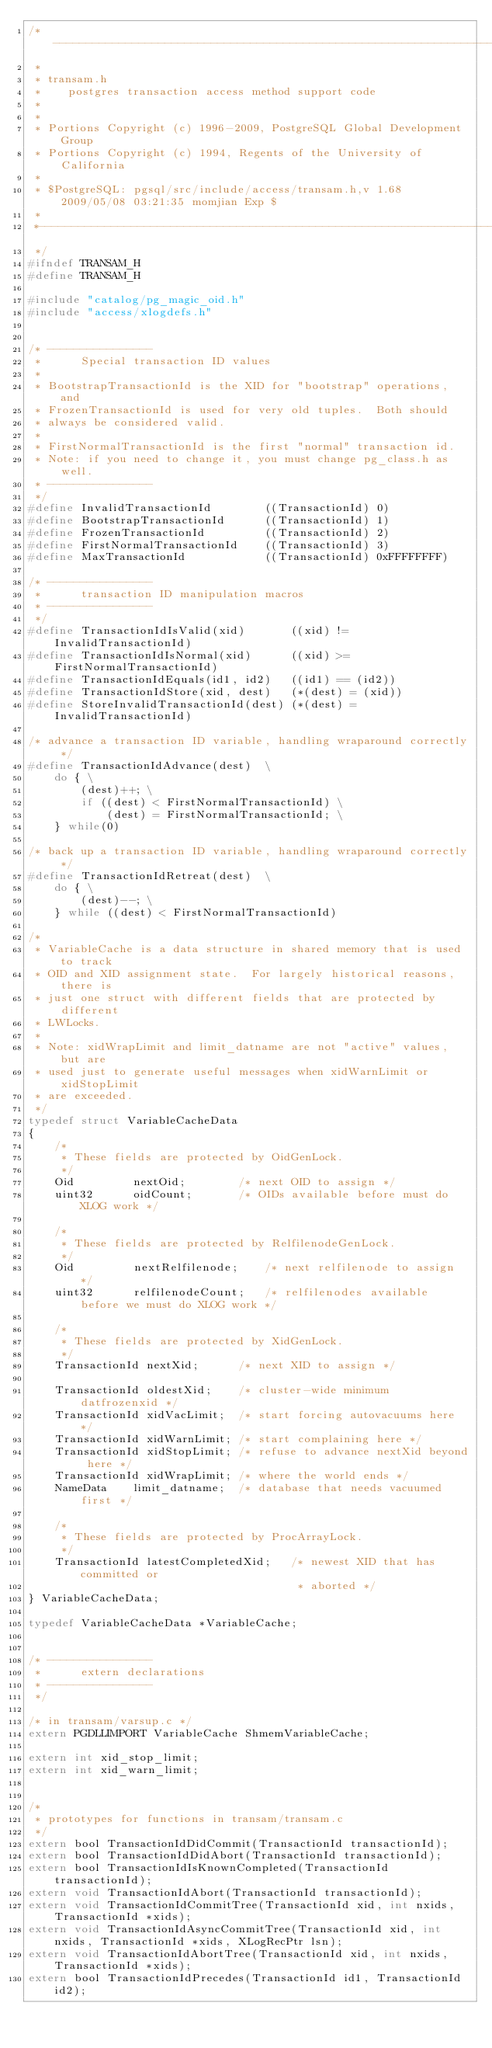<code> <loc_0><loc_0><loc_500><loc_500><_C_>/*-------------------------------------------------------------------------
 *
 * transam.h
 *	  postgres transaction access method support code
 *
 *
 * Portions Copyright (c) 1996-2009, PostgreSQL Global Development Group
 * Portions Copyright (c) 1994, Regents of the University of California
 *
 * $PostgreSQL: pgsql/src/include/access/transam.h,v 1.68 2009/05/08 03:21:35 momjian Exp $
 *
 *-------------------------------------------------------------------------
 */
#ifndef TRANSAM_H
#define TRANSAM_H

#include "catalog/pg_magic_oid.h"
#include "access/xlogdefs.h"


/* ----------------
 *		Special transaction ID values
 *
 * BootstrapTransactionId is the XID for "bootstrap" operations, and
 * FrozenTransactionId is used for very old tuples.  Both should
 * always be considered valid.
 *
 * FirstNormalTransactionId is the first "normal" transaction id.
 * Note: if you need to change it, you must change pg_class.h as well.
 * ----------------
 */
#define InvalidTransactionId		((TransactionId) 0)
#define BootstrapTransactionId		((TransactionId) 1)
#define FrozenTransactionId			((TransactionId) 2)
#define FirstNormalTransactionId	((TransactionId) 3)
#define MaxTransactionId			((TransactionId) 0xFFFFFFFF)

/* ----------------
 *		transaction ID manipulation macros
 * ----------------
 */
#define TransactionIdIsValid(xid)		((xid) != InvalidTransactionId)
#define TransactionIdIsNormal(xid)		((xid) >= FirstNormalTransactionId)
#define TransactionIdEquals(id1, id2)	((id1) == (id2))
#define TransactionIdStore(xid, dest)	(*(dest) = (xid))
#define StoreInvalidTransactionId(dest) (*(dest) = InvalidTransactionId)

/* advance a transaction ID variable, handling wraparound correctly */
#define TransactionIdAdvance(dest)	\
	do { \
		(dest)++; \
		if ((dest) < FirstNormalTransactionId) \
			(dest) = FirstNormalTransactionId; \
	} while(0)

/* back up a transaction ID variable, handling wraparound correctly */
#define TransactionIdRetreat(dest)	\
	do { \
		(dest)--; \
	} while ((dest) < FirstNormalTransactionId)

/*
 * VariableCache is a data structure in shared memory that is used to track
 * OID and XID assignment state.  For largely historical reasons, there is
 * just one struct with different fields that are protected by different
 * LWLocks.
 *
 * Note: xidWrapLimit and limit_datname are not "active" values, but are
 * used just to generate useful messages when xidWarnLimit or xidStopLimit
 * are exceeded.
 */
typedef struct VariableCacheData
{
	/*
	 * These fields are protected by OidGenLock.
	 */
	Oid			nextOid;		/* next OID to assign */
	uint32		oidCount;		/* OIDs available before must do XLOG work */

	/*
	 * These fields are protected by RelfilenodeGenLock.
	 */
	Oid			nextRelfilenode;	/* next relfilenode to assign */
	uint32		relfilenodeCount;	/* relfilenodes available before we must do XLOG work */

	/*
	 * These fields are protected by XidGenLock.
	 */
	TransactionId nextXid;		/* next XID to assign */

	TransactionId oldestXid;	/* cluster-wide minimum datfrozenxid */
	TransactionId xidVacLimit;	/* start forcing autovacuums here */
	TransactionId xidWarnLimit; /* start complaining here */
	TransactionId xidStopLimit; /* refuse to advance nextXid beyond here */
	TransactionId xidWrapLimit; /* where the world ends */
	NameData	limit_datname;	/* database that needs vacuumed first */

	/*
	 * These fields are protected by ProcArrayLock.
	 */
	TransactionId latestCompletedXid;	/* newest XID that has committed or
										 * aborted */
} VariableCacheData;

typedef VariableCacheData *VariableCache;


/* ----------------
 *		extern declarations
 * ----------------
 */

/* in transam/varsup.c */
extern PGDLLIMPORT VariableCache ShmemVariableCache;

extern int xid_stop_limit;
extern int xid_warn_limit;


/*
 * prototypes for functions in transam/transam.c
 */
extern bool TransactionIdDidCommit(TransactionId transactionId);
extern bool TransactionIdDidAbort(TransactionId transactionId);
extern bool TransactionIdIsKnownCompleted(TransactionId transactionId);
extern void TransactionIdAbort(TransactionId transactionId);
extern void TransactionIdCommitTree(TransactionId xid, int nxids, TransactionId *xids);
extern void TransactionIdAsyncCommitTree(TransactionId xid, int nxids, TransactionId *xids, XLogRecPtr lsn);
extern void TransactionIdAbortTree(TransactionId xid, int nxids, TransactionId *xids);
extern bool TransactionIdPrecedes(TransactionId id1, TransactionId id2);</code> 